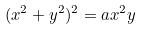<formula> <loc_0><loc_0><loc_500><loc_500>( x ^ { 2 } + y ^ { 2 } ) ^ { 2 } = a x ^ { 2 } y</formula> 